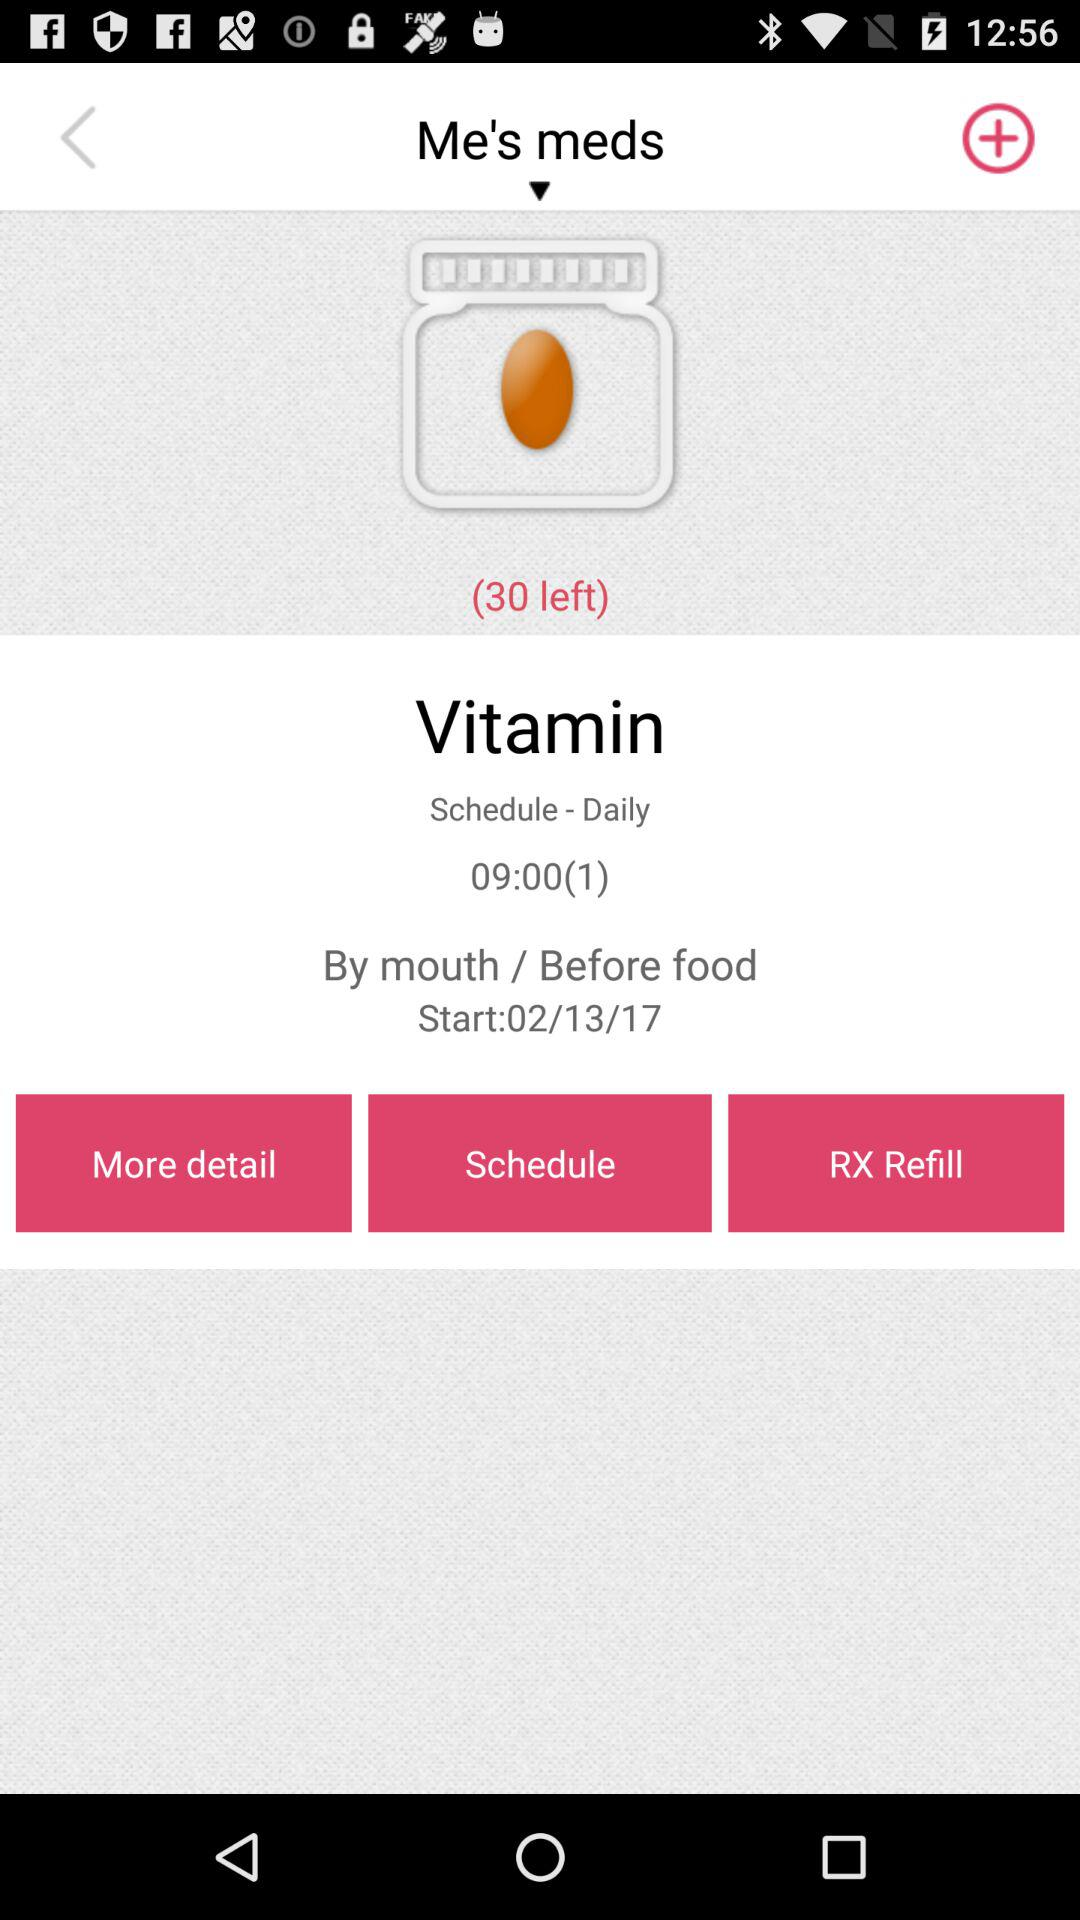What is the start date? The start date is February 13, 2017. 